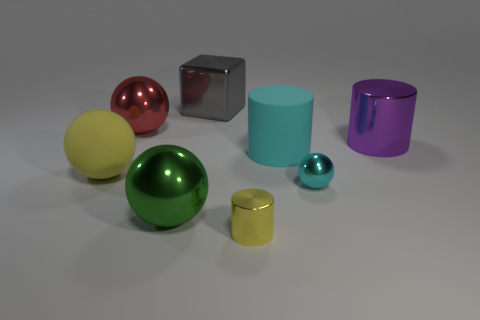Subtract 1 balls. How many balls are left? 3 Subtract all purple balls. Subtract all cyan cylinders. How many balls are left? 4 Add 1 large cyan cubes. How many objects exist? 9 Subtract all cubes. How many objects are left? 7 Add 3 yellow matte blocks. How many yellow matte blocks exist? 3 Subtract 0 brown cylinders. How many objects are left? 8 Subtract all large purple shiny objects. Subtract all tiny shiny things. How many objects are left? 5 Add 5 large cyan things. How many large cyan things are left? 6 